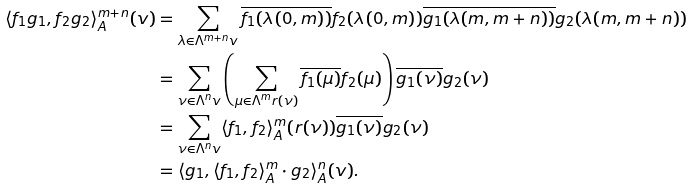<formula> <loc_0><loc_0><loc_500><loc_500>\langle f _ { 1 } g _ { 1 } , f _ { 2 } g _ { 2 } \rangle _ { A } ^ { m + n } ( v ) & = \sum _ { \lambda \in \Lambda ^ { m + n } v } \overline { f _ { 1 } ( \lambda ( 0 , m ) ) } f _ { 2 } ( \lambda ( 0 , m ) ) \overline { g _ { 1 } ( \lambda ( m , m + n ) ) } g _ { 2 } ( \lambda ( m , m + n ) ) \\ & = \sum _ { \nu \in \Lambda ^ { n } v } \left ( \sum _ { \mu \in \Lambda ^ { m } r ( \nu ) } \overline { f _ { 1 } ( \mu ) } f _ { 2 } ( \mu ) \right ) \overline { g _ { 1 } ( \nu ) } g _ { 2 } ( \nu ) \\ & = \sum _ { \nu \in \Lambda ^ { n } v } \langle f _ { 1 } , f _ { 2 } \rangle _ { A } ^ { m } ( r ( \nu ) ) \overline { g _ { 1 } ( \nu ) } g _ { 2 } ( \nu ) \\ & = \langle g _ { 1 } , \langle f _ { 1 } , f _ { 2 } \rangle _ { A } ^ { m } \cdot g _ { 2 } \rangle _ { A } ^ { n } ( v ) .</formula> 